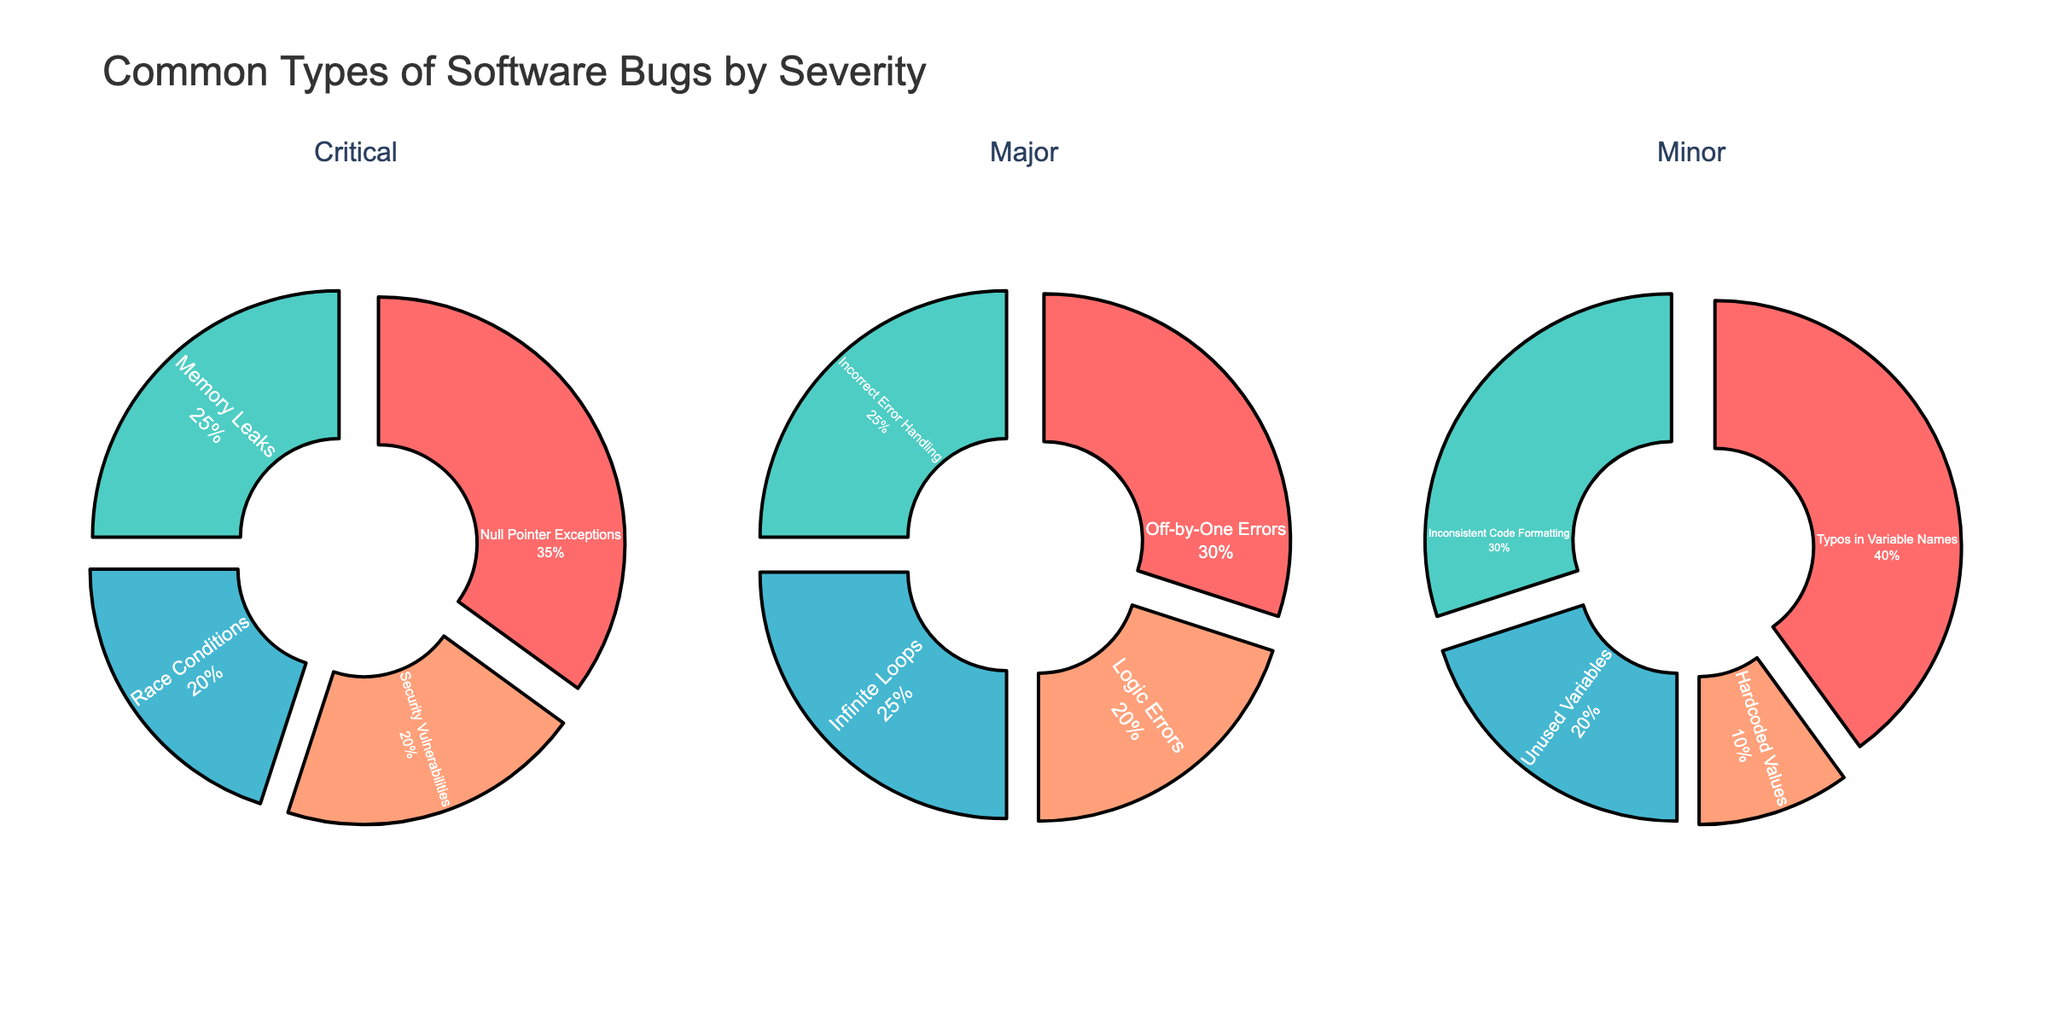Which type of bug has the highest percentage among critical severity bugs? Critical severity pie chart shows that "Null Pointer Exceptions" have the largest slice, indicating the highest percentage at 35%.
Answer: Null Pointer Exceptions Among major severity bugs, which two bug types have the same percentage? The major severity pie chart shows that "Incorrect Error Handling" and "Infinite Loops" each have a 25% slice.
Answer: Incorrect Error Handling and Infinite Loops Which severity category has typos in variable names, and what is its percentage? The minor severity pie chart shows a slice labeled "Typos in Variable Names" with a 40% share.
Answer: Minor, 40% Are there any bug types that appear across all severity levels? By examining each pie chart, there are no bug types that are common across all the critical, major, and minor severity levels.
Answer: No Compare the share of race conditions to memory leaks in critical severity. The critical severity pie chart shows that "Race Conditions" have a 20% share compared to "Memory Leaks" which have a 25% share. Thus, "Memory Leaks" are larger.
Answer: Memory Leaks > Race Conditions What is the combined percentage of logic errors and infinite loops in the major severity category? The major severity pie chart shows "Logic Errors" at 20% and "Infinite Loops" at 25%. Adding these together gives 20 + 25 = 45%.
Answer: 45% Which severity level has the highest variety of bug types? All three pie charts (critical, major, and minor) display four different bug types each. Hence, all severity levels have an equal variety of bug types.
Answer: All have equal variety How does the percentage of security vulnerabilities compare to inconsistent code formatting? "Security Vulnerabilities" are at 20% in the critical severity pie chart, while "Inconsistent Code Formatting" has 30% in the minor severity pie chart. Thus, "Inconsistent Code Formatting" is higher.
Answer: Inconsistent Code Formatting > Security Vulnerabilities Which bug type in the minor severity category has the smallest percentage? The minor severity pie chart shows that "Hardcoded Values" have the smallest slice at 10%.
Answer: Hardcoded Values If we combine all percentages in each chart, do they sum up to 100%? Each pie chart section represents parts of the whole for its severity category. Summing up all parts in critical (35 + 25 + 20 + 20), major (30 + 25 + 25 + 20), and minor (40 + 30 + 20 + 10) each gives 100%.
Answer: Yes 